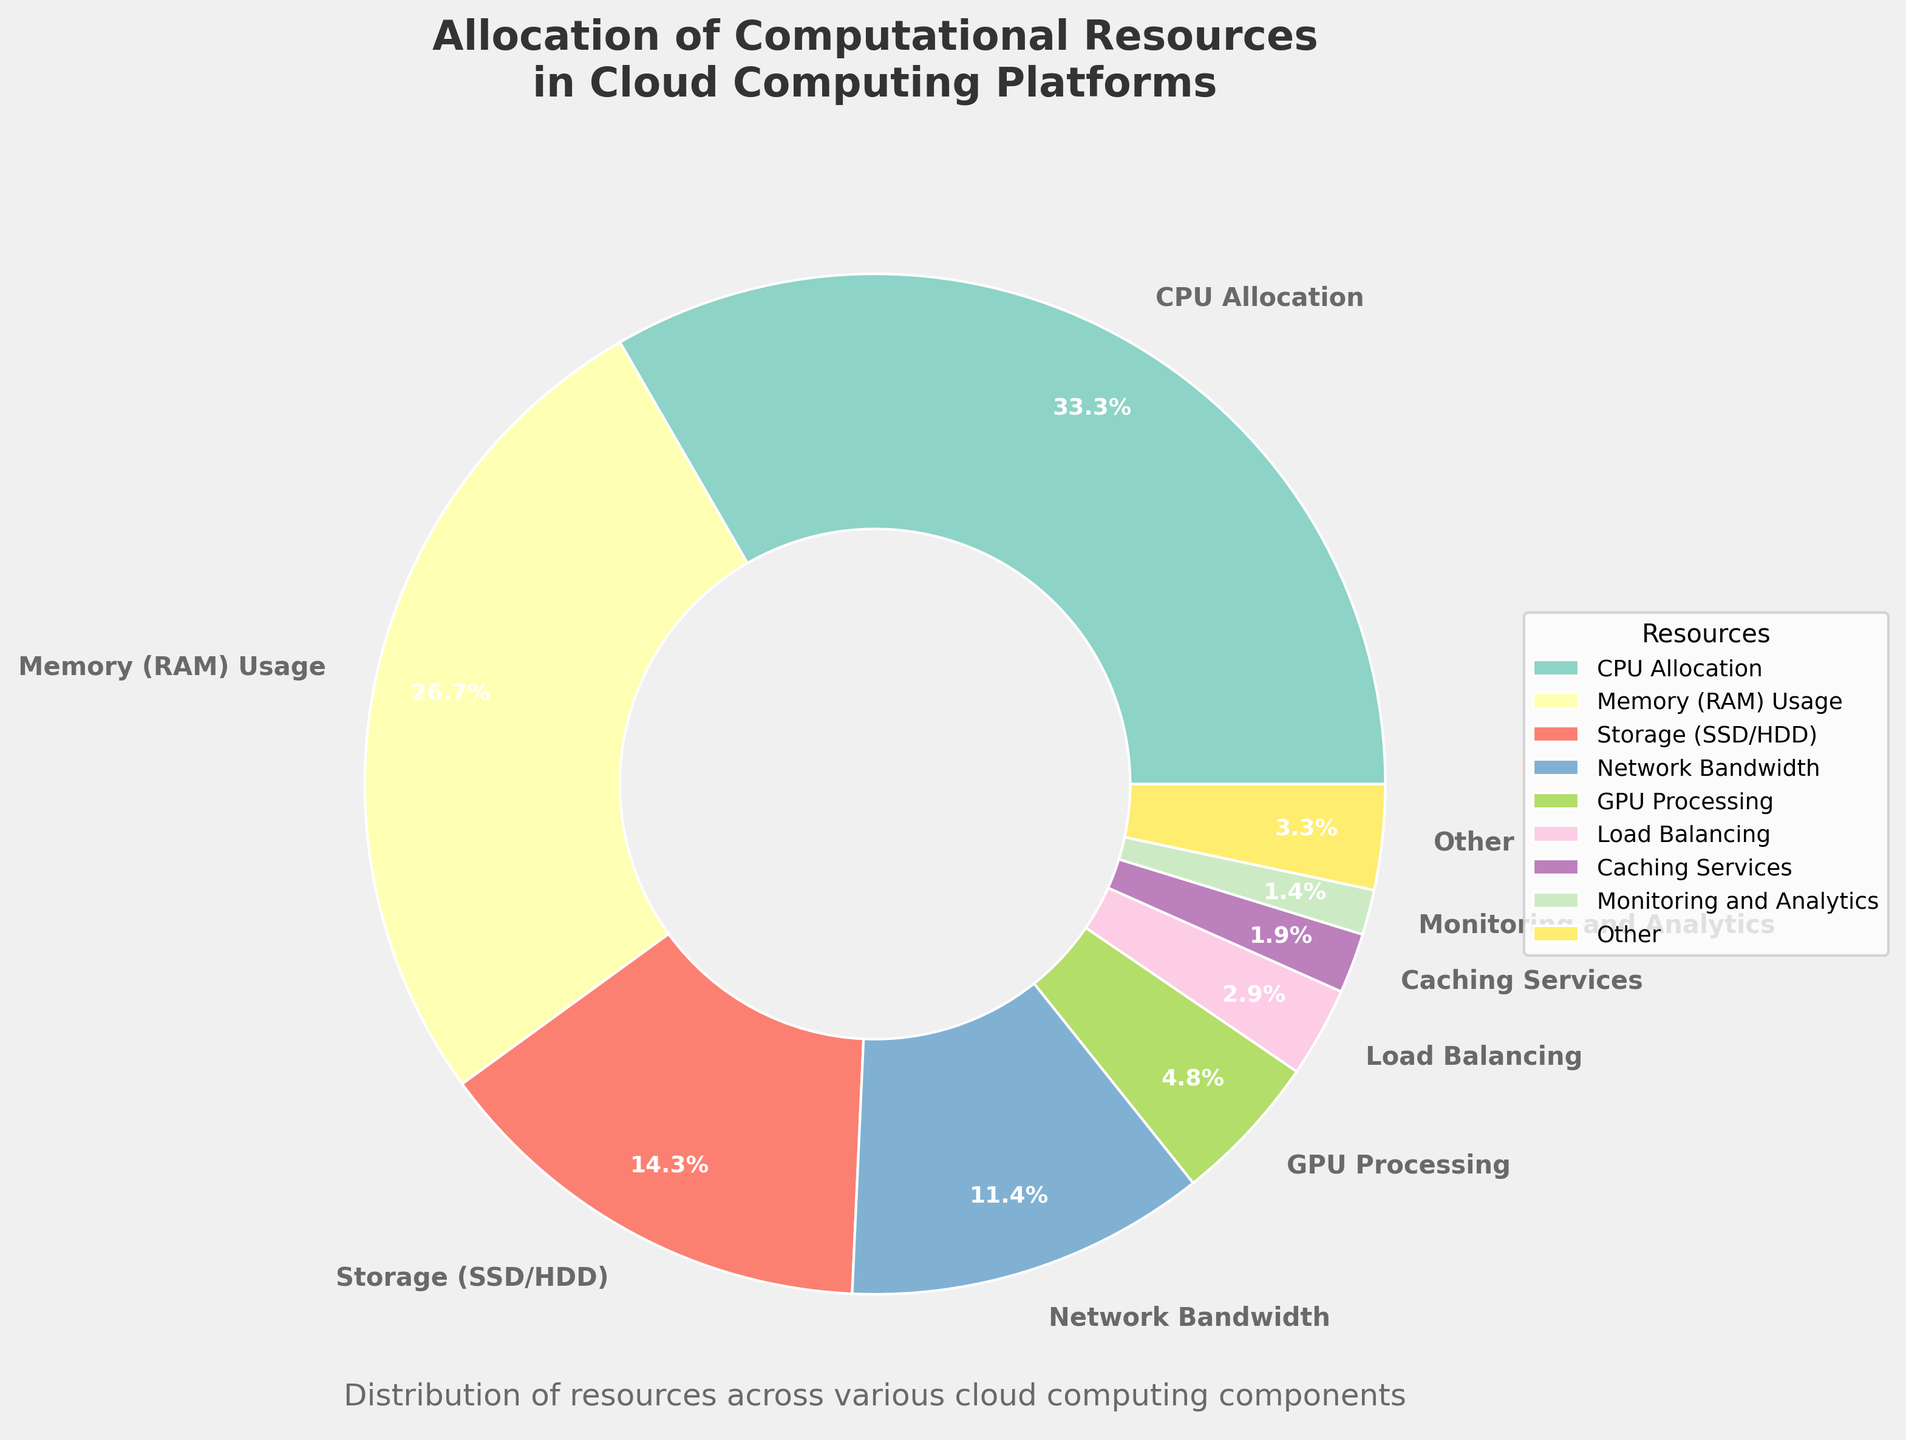What is the most allocated resource in cloud computing platforms according to the figure? The pie chart shows that the largest segment represents 'CPU Allocation' with a percentage of 35%, making it the most allocated resource.
Answer: CPU Allocation How does the allocation of 'GPU Processing' compare to 'Load Balancing'? The percentage for 'GPU Processing' is 5%, while 'Load Balancing' has 3%. This means 'GPU Processing' is allocated more computational resources than 'Load Balancing'.
Answer: GPU Processing has a higher allocation What is the combined percentage of 'Memory (RAM) Usage' and 'Storage (SSD/HDD)'? 'Memory (RAM) Usage' is 28%, and 'Storage (SSD/HDD)' is 15%. Combining these percentages gives 28% + 15% = 43%.
Answer: 43% Which resource has the smallest allocation, and what is its percentage? The figure shows that 'API Gateway Resources' has the smallest allocation, with a percentage of 0.2%.
Answer: API Gateway Resources, 0.2% What is the total percentage allocated to 'Security and Encryption', 'Containerization Overhead', and 'Serverless Functions'? 'Security and Encryption' is 1%, 'Containerization Overhead' is 0.8%, and 'Serverless Functions' is 0.7%. Adding these percentages gives 1% + 0.8% + 0.7% = 2.5%.
Answer: 2.5% How much more is allocated to 'CPU Allocation' compared to 'Network Bandwidth'? 'CPU Allocation' is 35% and 'Network Bandwidth' is 12%. The difference is 35% - 12% = 23%.
Answer: 23% more Considering the category 'Other', what percentage of resources do the less significant categories combine for? The 'Other' category aggregates resources not in the top 8, with a combined percentage of 12.5%.
Answer: 12.5% What is the difference in allocation percentage between 'Memory (RAM) Usage' and 'GPU Processing'? 'Memory (RAM) Usage' is 28%, and 'GPU Processing' is 5%. The difference is 28% - 5% = 23%.
Answer: 23% What are the top three resources in the chart in terms of percentage allocation? The top three resources by allocation are 'CPU Allocation' at 35%, 'Memory (RAM) Usage' at 28%, and 'Storage (SSD/HDD)' at 15%.
Answer: CPU Allocation, Memory (RAM) Usage, Storage (SSD/HDD) What is the percentage and the visual representation color for 'Caching Services'? 'Caching Services' holds a 2% allocation and is represented by a unique color in the pie chart within the chosen palette. Since precise color codes aren't specified, its identification is within the generated legend.
Answer: 2%, specified color in legend 